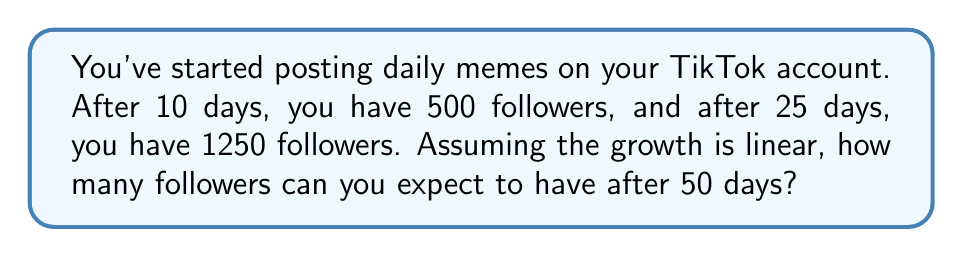Can you answer this question? Let's approach this step-by-step:

1) We can represent the number of followers ($y$) as a function of days ($x$) using a linear equation:
   $y = mx + b$, where $m$ is the slope and $b$ is the y-intercept.

2) To find the slope $m$, we use the two given points (10, 500) and (25, 1250):
   $m = \frac{y_2 - y_1}{x_2 - x_1} = \frac{1250 - 500}{25 - 10} = \frac{750}{15} = 50$

3) This means you're gaining 50 followers per day on average.

4) Now we can use either point to find $b$. Let's use (10, 500):
   $500 = 50(10) + b$
   $500 = 500 + b$
   $b = 0$

5) So our linear equation is:
   $y = 50x + 0$ or simply $y = 50x$

6) To find the number of followers after 50 days, we plug in $x = 50$:
   $y = 50(50) = 2500$

Therefore, after 50 days, you can expect to have 2500 followers.
Answer: 2500 followers 